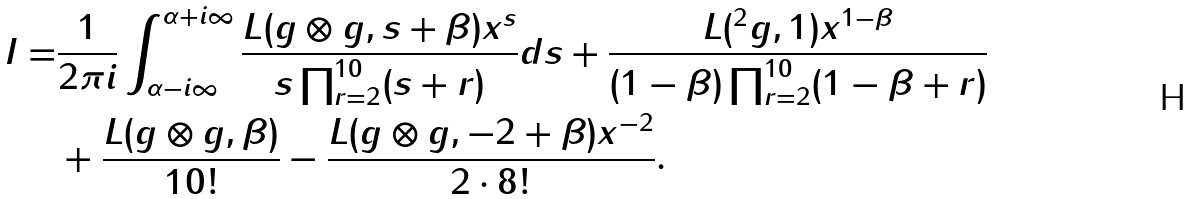Convert formula to latex. <formula><loc_0><loc_0><loc_500><loc_500>I = & \frac { 1 } { 2 \pi i } \int _ { \alpha - i \infty } ^ { \alpha + i \infty } \frac { L ( g \otimes g , s + \beta ) x ^ { s } } { s \prod _ { r = 2 } ^ { 1 0 } ( s + r ) } d s + \frac { L ( ^ { 2 } g , 1 ) x ^ { 1 - \beta } } { ( 1 - \beta ) \prod _ { r = 2 } ^ { 1 0 } ( 1 - \beta + r ) } \\ & + \frac { L ( g \otimes g , \beta ) } { 1 0 ! } - \frac { L ( g \otimes g , - 2 + \beta ) x ^ { - 2 } } { 2 \cdot 8 ! } .</formula> 